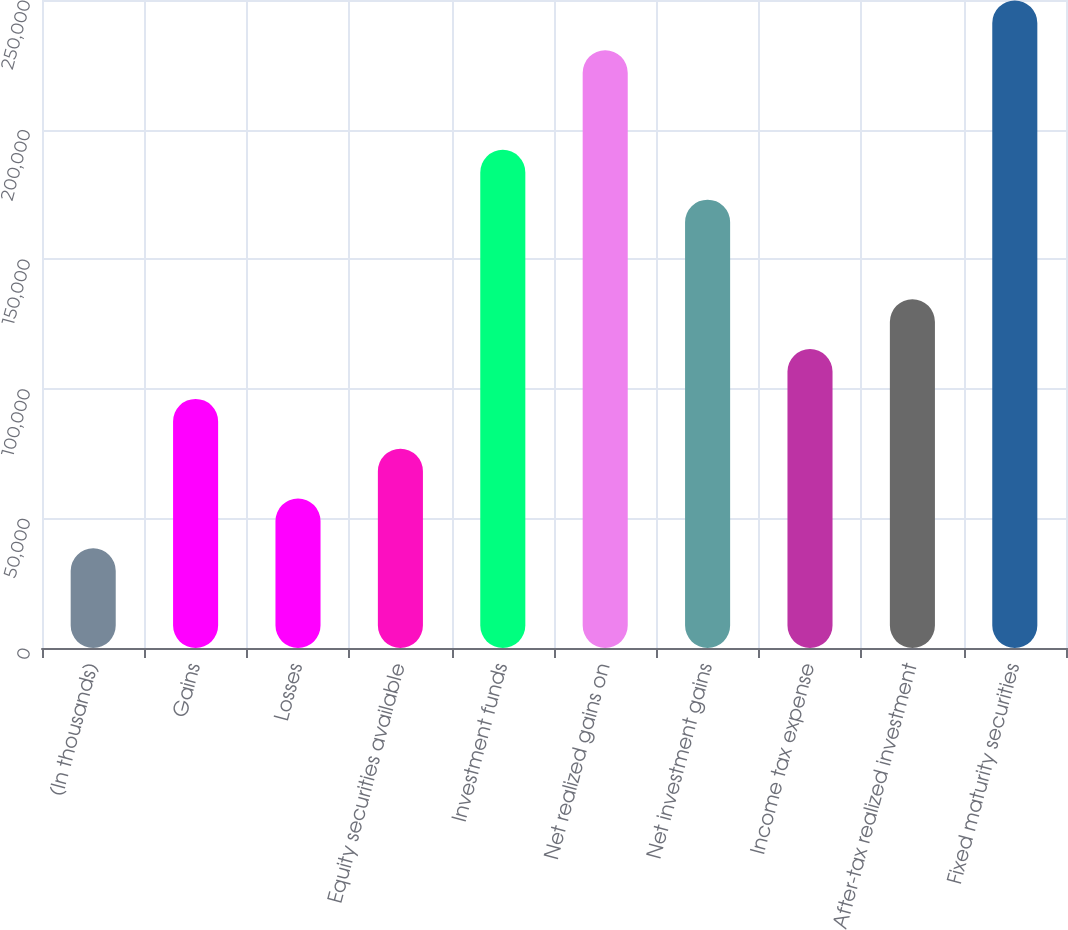Convert chart to OTSL. <chart><loc_0><loc_0><loc_500><loc_500><bar_chart><fcel>(In thousands)<fcel>Gains<fcel>Losses<fcel>Equity securities available<fcel>Investment funds<fcel>Net realized gains on<fcel>Net investment gains<fcel>Income tax expense<fcel>After-tax realized investment<fcel>Fixed maturity securities<nl><fcel>38467.6<fcel>96112<fcel>57682.4<fcel>76897.2<fcel>192186<fcel>230616<fcel>172971<fcel>115327<fcel>134542<fcel>249830<nl></chart> 